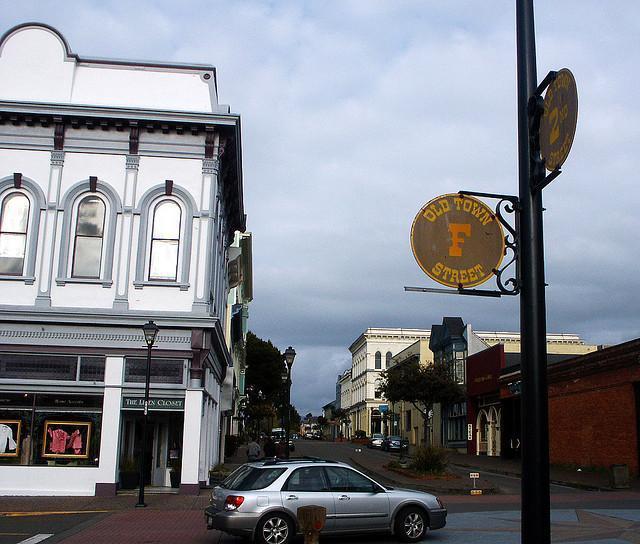How many people are on the ski lift?
Give a very brief answer. 0. 